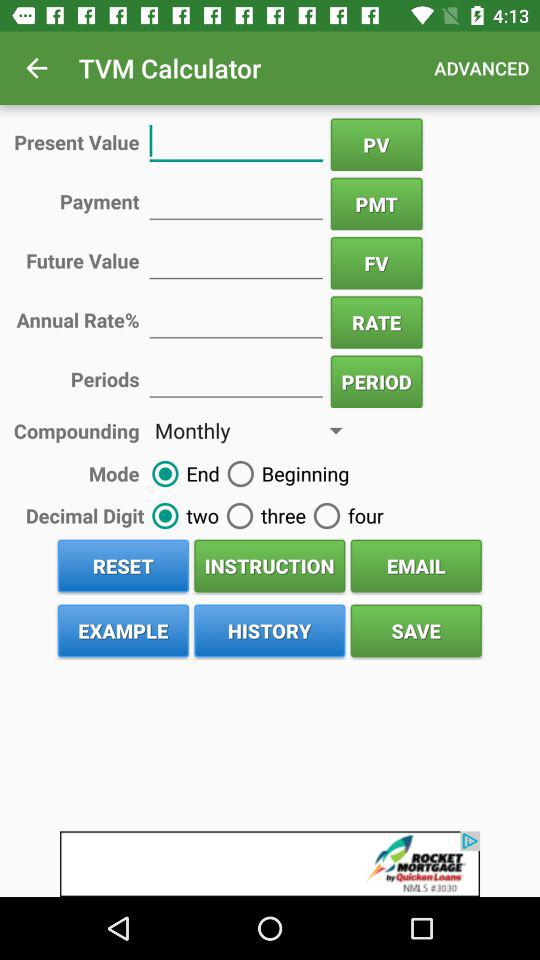Which decimal digit is selected? The selected decimal digit is "two". 